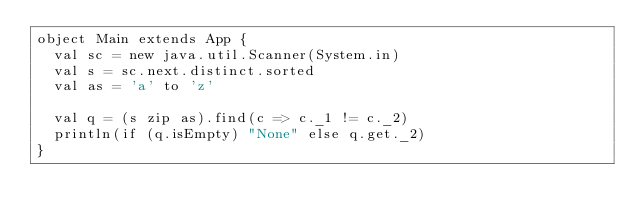Convert code to text. <code><loc_0><loc_0><loc_500><loc_500><_Scala_>object Main extends App {
  val sc = new java.util.Scanner(System.in)
  val s = sc.next.distinct.sorted
  val as = 'a' to 'z'

  val q = (s zip as).find(c => c._1 != c._2)
  println(if (q.isEmpty) "None" else q.get._2)
}
</code> 